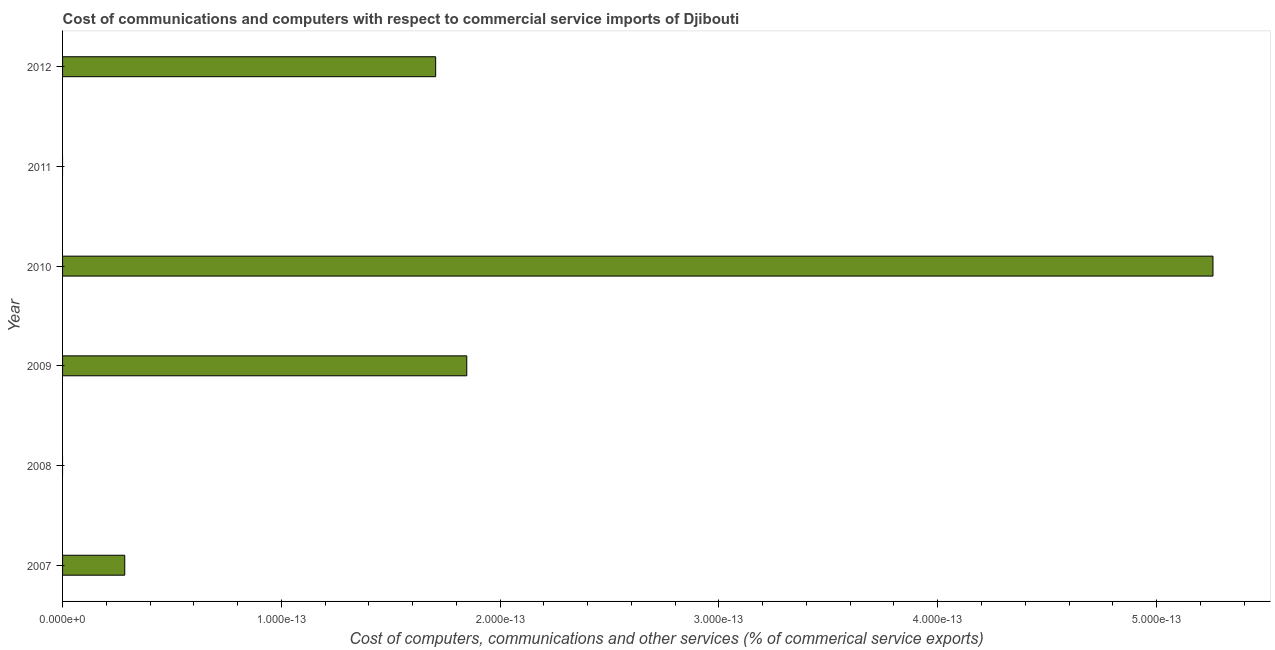What is the title of the graph?
Your answer should be very brief. Cost of communications and computers with respect to commercial service imports of Djibouti. What is the label or title of the X-axis?
Offer a terse response. Cost of computers, communications and other services (% of commerical service exports). What is the label or title of the Y-axis?
Your response must be concise. Year. What is the cost of communications in 2009?
Ensure brevity in your answer.  1.84741111297626e-13. Across all years, what is the maximum cost of communications?
Your answer should be compact. 5.258016244624737e-13. What is the sum of the  computer and other services?
Keep it short and to the point. 9.094947017729278e-13. What is the median cost of communications?
Keep it short and to the point. 9.9475983006414e-14. In how many years, is the cost of communications greater than 2e-13 %?
Your answer should be very brief. 1. What is the ratio of the cost of communications in 2007 to that in 2010?
Your answer should be compact. 0.05. Is the sum of the cost of communications in 2009 and 2012 greater than the maximum cost of communications across all years?
Your answer should be very brief. No. What is the difference between the highest and the lowest  computer and other services?
Keep it short and to the point. 0. How many bars are there?
Your answer should be very brief. 4. Are all the bars in the graph horizontal?
Give a very brief answer. Yes. What is the difference between two consecutive major ticks on the X-axis?
Give a very brief answer. 1e-13. Are the values on the major ticks of X-axis written in scientific E-notation?
Keep it short and to the point. Yes. What is the Cost of computers, communications and other services (% of commerical service exports) in 2007?
Your answer should be very brief. 2.8421709430404e-14. What is the Cost of computers, communications and other services (% of commerical service exports) of 2009?
Give a very brief answer. 1.84741111297626e-13. What is the Cost of computers, communications and other services (% of commerical service exports) of 2010?
Ensure brevity in your answer.  5.258016244624737e-13. What is the Cost of computers, communications and other services (% of commerical service exports) of 2011?
Give a very brief answer. 0. What is the Cost of computers, communications and other services (% of commerical service exports) in 2012?
Your answer should be very brief. 1.70530256582424e-13. What is the difference between the Cost of computers, communications and other services (% of commerical service exports) in 2007 and 2009?
Your answer should be compact. -0. What is the difference between the Cost of computers, communications and other services (% of commerical service exports) in 2007 and 2010?
Give a very brief answer. -0. What is the difference between the Cost of computers, communications and other services (% of commerical service exports) in 2010 and 2012?
Give a very brief answer. 0. What is the ratio of the Cost of computers, communications and other services (% of commerical service exports) in 2007 to that in 2009?
Ensure brevity in your answer.  0.15. What is the ratio of the Cost of computers, communications and other services (% of commerical service exports) in 2007 to that in 2010?
Your answer should be very brief. 0.05. What is the ratio of the Cost of computers, communications and other services (% of commerical service exports) in 2007 to that in 2012?
Your response must be concise. 0.17. What is the ratio of the Cost of computers, communications and other services (% of commerical service exports) in 2009 to that in 2010?
Give a very brief answer. 0.35. What is the ratio of the Cost of computers, communications and other services (% of commerical service exports) in 2009 to that in 2012?
Your response must be concise. 1.08. What is the ratio of the Cost of computers, communications and other services (% of commerical service exports) in 2010 to that in 2012?
Offer a terse response. 3.08. 